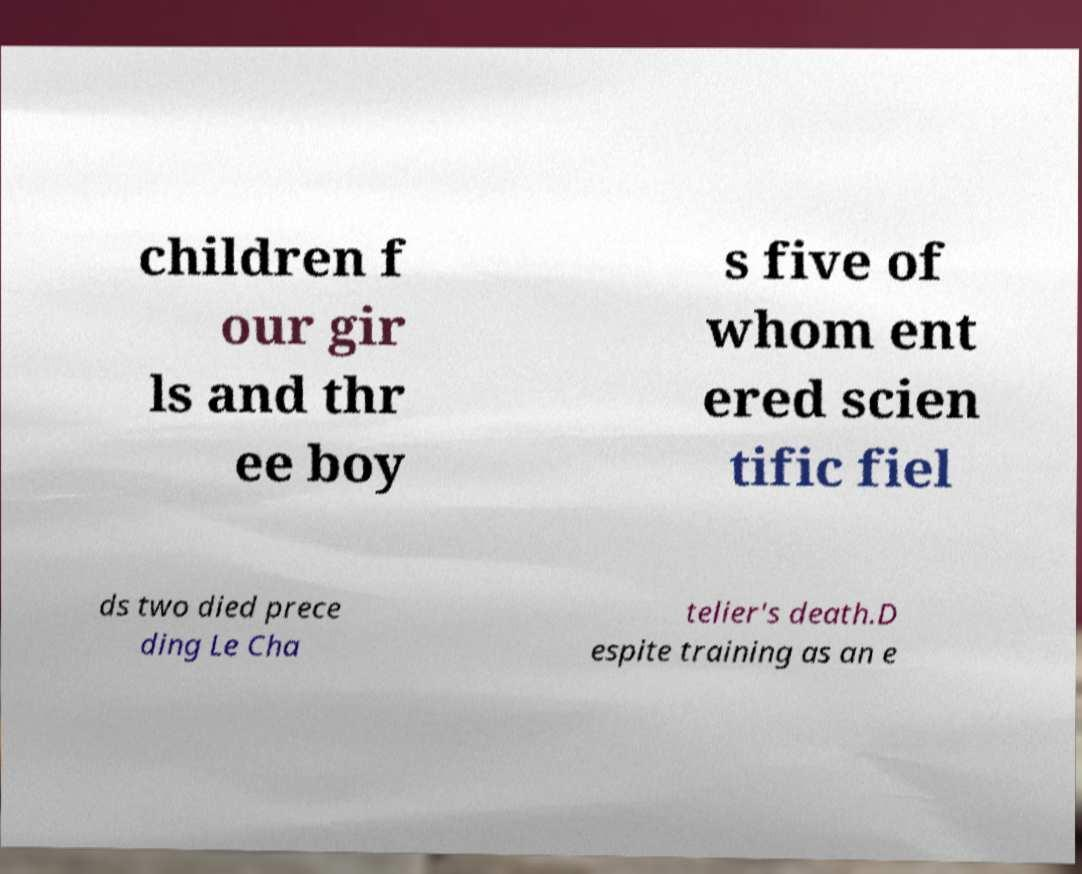Can you accurately transcribe the text from the provided image for me? children f our gir ls and thr ee boy s five of whom ent ered scien tific fiel ds two died prece ding Le Cha telier's death.D espite training as an e 